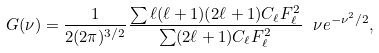Convert formula to latex. <formula><loc_0><loc_0><loc_500><loc_500>G ( \nu ) = \frac { 1 } { 2 ( 2 \pi ) ^ { 3 / 2 } } \frac { \sum \ell ( \ell + 1 ) ( 2 \ell + 1 ) C _ { \ell } F _ { \ell } ^ { 2 } } { \sum ( 2 \ell + 1 ) C _ { \ell } F _ { \ell } ^ { 2 } } \ \nu e ^ { - \nu ^ { 2 } / 2 } ,</formula> 